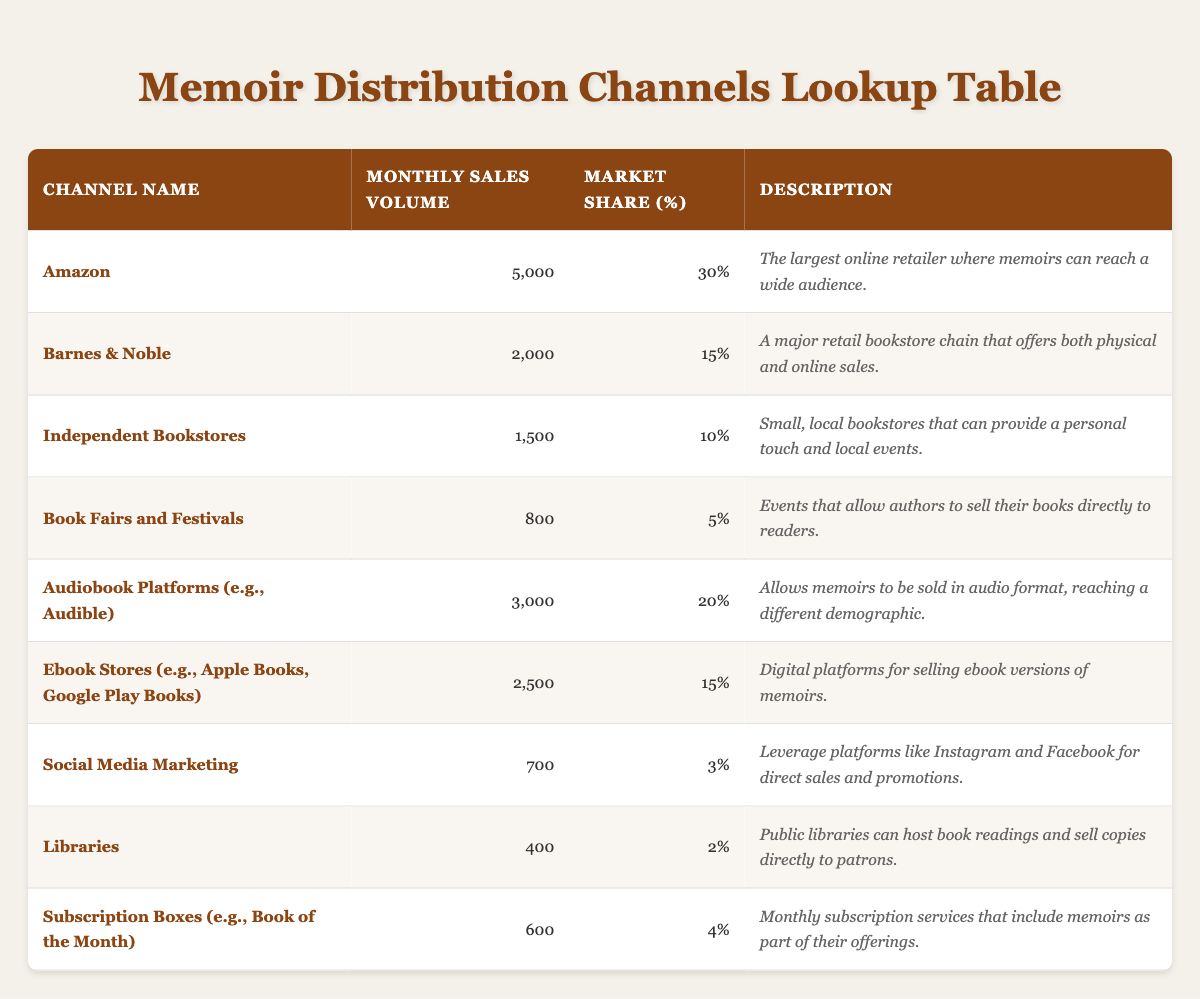What is the monthly sales volume for Amazon? The table indicates the monthly sales volume specifically for Amazon as 5000.
Answer: 5000 What percentage of the market share does Audiobook Platforms hold? According to the table, Audiobook Platforms have a market share percentage of 20%.
Answer: 20% Which distribution channel has the lowest monthly sales volume? The table shows that Libraries have the lowest monthly sales volume, which is 400.
Answer: 400 What is the combined monthly sales volume for Ebook Stores and Social Media Marketing? The monthly sales volume for Ebook Stores is 2500, and for Social Media Marketing, it is 700. Adding them together gives 2500 + 700 = 3200.
Answer: 3200 Is the market share percentage for Independent Bookstores higher than 10%? The table states that the market share percentage for Independent Bookstores is exactly 10%, which is not higher than 10%.
Answer: No Which channel has a higher market share: Book Fairs and Festivals or Subscription Boxes? According to the table, Book Fairs and Festivals have a market share of 5%, while Subscription Boxes have a market share of 4%. Therefore, Book Fairs and Festivals have a higher market share.
Answer: Book Fairs and Festivals What percentage of the total monthly sales volume do Audiobook Platforms and Amazon represent together? The monthly sales volume for Audiobook Platforms is 3000, and for Amazon, it is 5000. The total monthly sales volume for all channels is 5,000 + 2,000 + 1,500 + 800 + 3,000 + 2,500 + 700 + 400 + 600 = 16,500. The combined sales from Amazon and Audiobook Platforms is 5000 + 3000 = 8000. To find the percentage: (8000 / 16500) * 100 ≈ 48.48%.
Answer: Approximately 48.48% How many channels have a monthly sales volume greater than 2000? From the table, the channels with a sales volume greater than 2000 are Amazon (5000), Barnes & Noble (2000), and Audiobook Platforms (3000). Therefore, there are three channels that meet this condition.
Answer: 3 Are there more channels with a market share under 5% than above 5%? The table indicates that Channels with under 5% market share are Social Media Marketing (3%), Libraries (2%), and Subscription Boxes (4%) which totals 3 channels. Channels with a share above 5% are Amazon (30%), Barnes & Noble (15%), Audiobook Platforms (20%), Ebook Stores (15%), and Independent Bookstores (10%), totaling 5 channels. Therefore, there are more channels above 5%.
Answer: No 